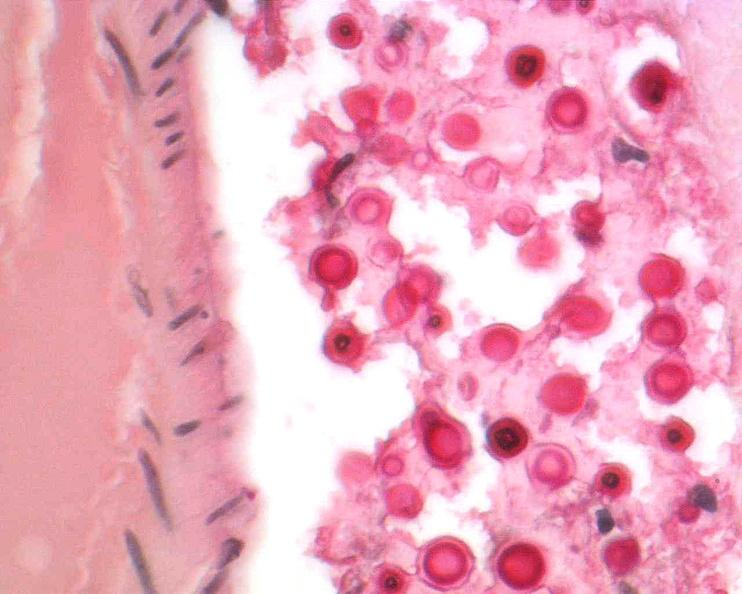where is this?
Answer the question using a single word or phrase. Nervous 